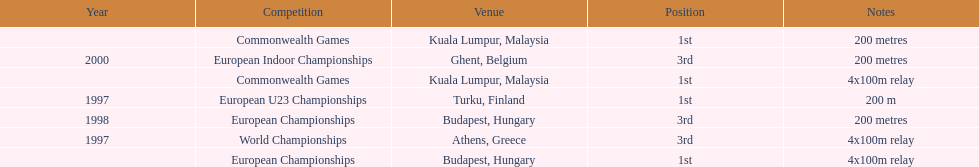How many 4x 100m relays were run? 3. 